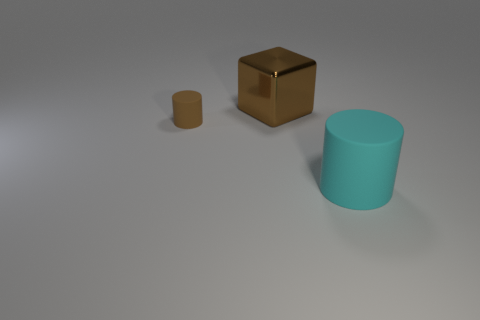Add 1 small shiny blocks. How many objects exist? 4 Subtract all cubes. How many objects are left? 2 Subtract all cyan rubber cylinders. Subtract all tiny cyan rubber things. How many objects are left? 2 Add 1 big cyan objects. How many big cyan objects are left? 2 Add 3 tiny green cylinders. How many tiny green cylinders exist? 3 Subtract 0 blue balls. How many objects are left? 3 